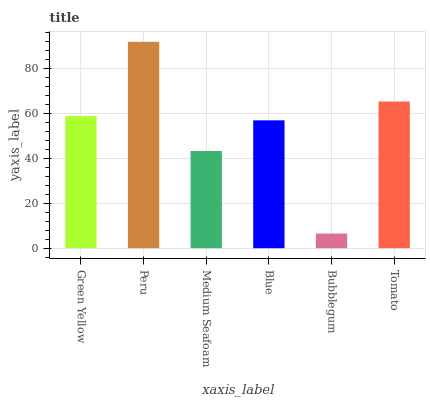Is Bubblegum the minimum?
Answer yes or no. Yes. Is Peru the maximum?
Answer yes or no. Yes. Is Medium Seafoam the minimum?
Answer yes or no. No. Is Medium Seafoam the maximum?
Answer yes or no. No. Is Peru greater than Medium Seafoam?
Answer yes or no. Yes. Is Medium Seafoam less than Peru?
Answer yes or no. Yes. Is Medium Seafoam greater than Peru?
Answer yes or no. No. Is Peru less than Medium Seafoam?
Answer yes or no. No. Is Green Yellow the high median?
Answer yes or no. Yes. Is Blue the low median?
Answer yes or no. Yes. Is Medium Seafoam the high median?
Answer yes or no. No. Is Peru the low median?
Answer yes or no. No. 